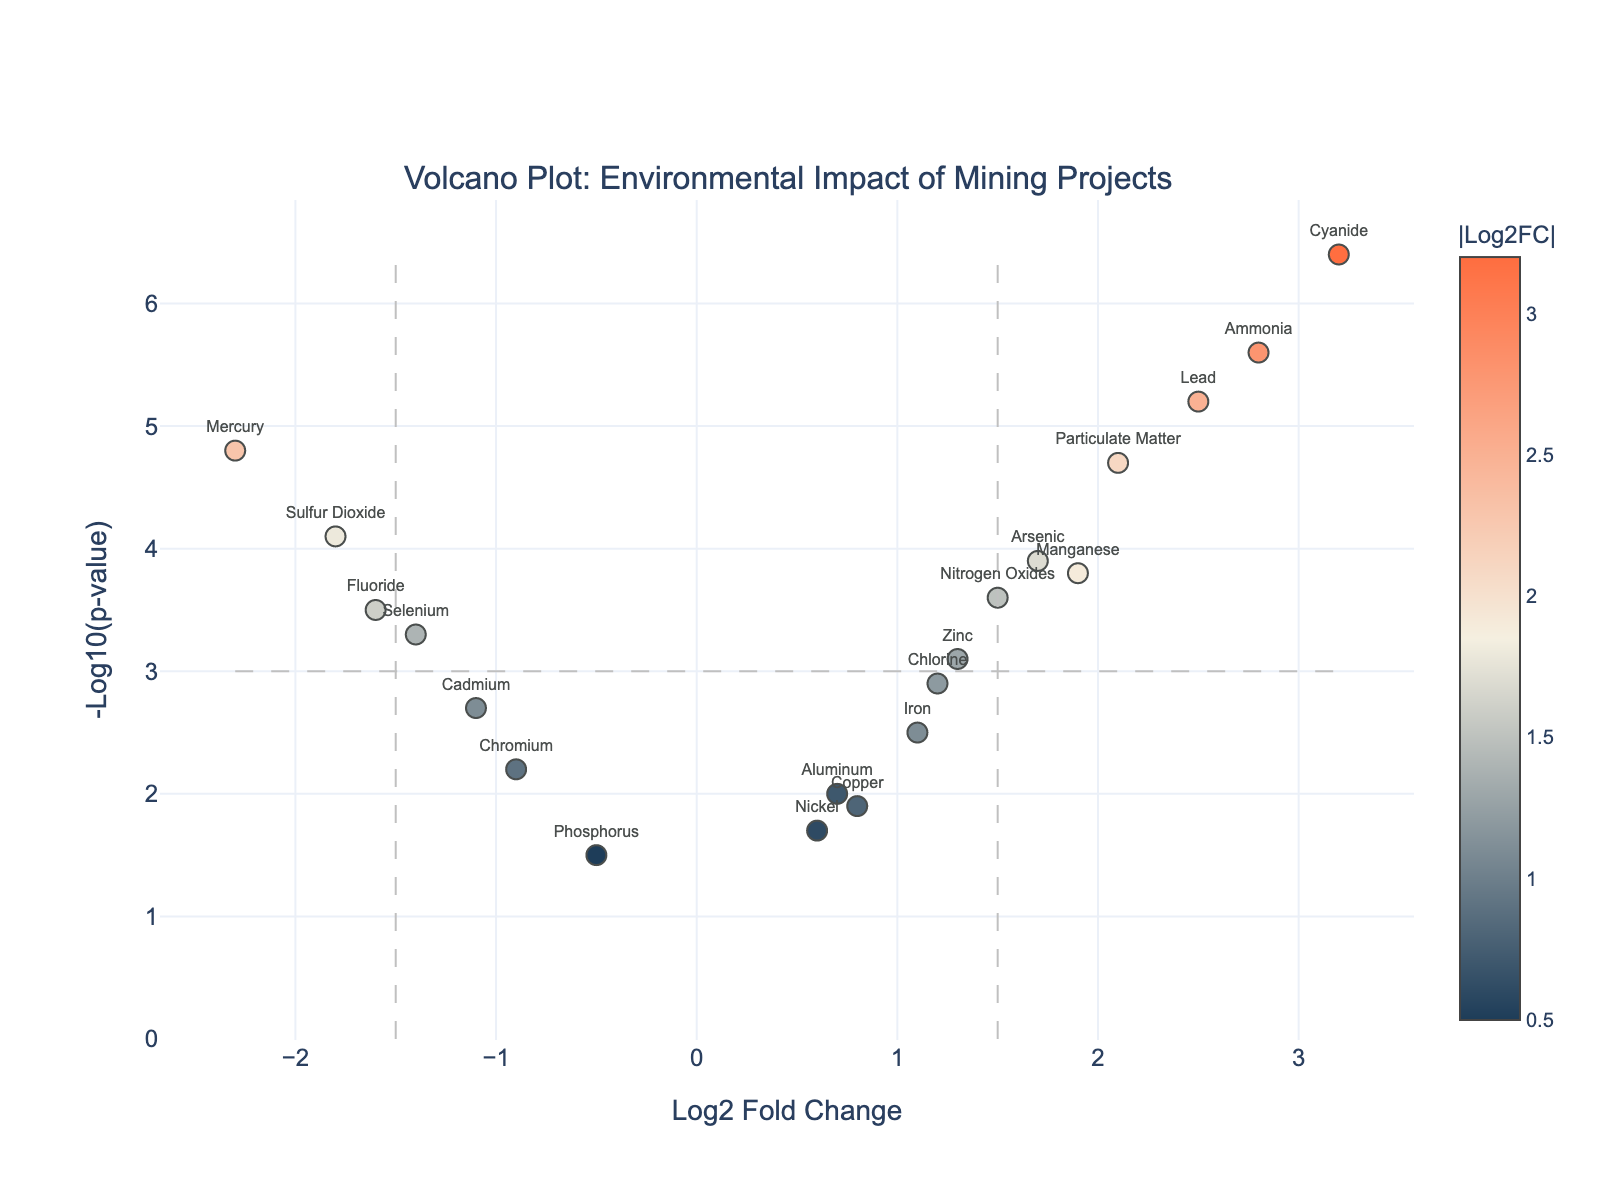What pollutant exhibits the highest negative fold change? To determine the pollutant with the highest negative fold change, look at the x-axis for the lowest Log2FoldChange value. The point at -2.3 corresponds to Mercury.
Answer: Mercury Which pollutant has the highest significance according to the p-value? To find the pollutant with the highest significance, look at the y-axis for the highest -Log10(p-value) value. The point at 6.4 corresponds to Cyanide.
Answer: Cyanide How many pollutants exhibit a positive fold change greater than 1.5? To answer this, count the points to the right of the x-axis threshold line at 1.5. The pollutants are Arsenic, Lead, Cyanide, Particulate Matter, Manganese, Ammonia, Chlorine. This gives a total of 7 pollutants.
Answer: 7 What are the pollutants that have a -Log10(p-value) above 3 and a Log2FoldChange lower than 0? To solve this, identify the points above the y-axis threshold line at 3 and to the left of the x-axis line at 0. These pollutants are Mercury, Cadmium, Sulfur Dioxide, Chromium, Selenium, and Fluoride.
Answer: Mercury, Cadmium, Sulfur Dioxide, Chromium, Selenium, Fluoride Compare the significance of Lead and Particulate Matter. Which one is more significant? Compare the y-axis values of Lead (5.2) and Particulate Matter (4.7). The higher value indicates greater significance. Thus, Lead is more significant.
Answer: Lead Which pollutants show a positive fold change yet have a -Log10(p-value) below 3? Identify points to the right of the x-axis line at 0 but below the y-axis line at 3. The pollutants are Copper, Nickel, Aluminum, and Iron.
Answer: Copper, Nickel, Aluminum, Iron What is the fold change and significance of the pollutant with the highest positive fold change? Find the point furthest to the right on the x-axis. For Cyanide, the Log2FoldChange is 3.2, and -Log10(p-value) is 6.4.
Answer: Log2FoldChange: 3.2, -Log10(p-value): 6.4 Among the pollutants with a positive Log2FoldChange, which one has the lowest significance? Look at the points to the right of the x-axis line at 0 and find the one with the lowest y-axis value. Nickel has the lowest -Log10(p-value) of 1.7.
Answer: Nickel Determine the mean -Log10(p-value) of the pollutants with a negative fold change. First, identify pollutants with a Log2FoldChange below 0: Mercury, Cadmium, Sulfur Dioxide, Chromium, Selenium, and Fluoride. Their -Log10(p-values) are 4.8, 2.7, 4.1, 2.2, 3.3, and 3.5 respectively. Calculating the mean: (4.8 + 2.7 + 4.1 + 2.2 + 3.3 + 3.5) / 6 = 3.433.
Answer: 3.43 